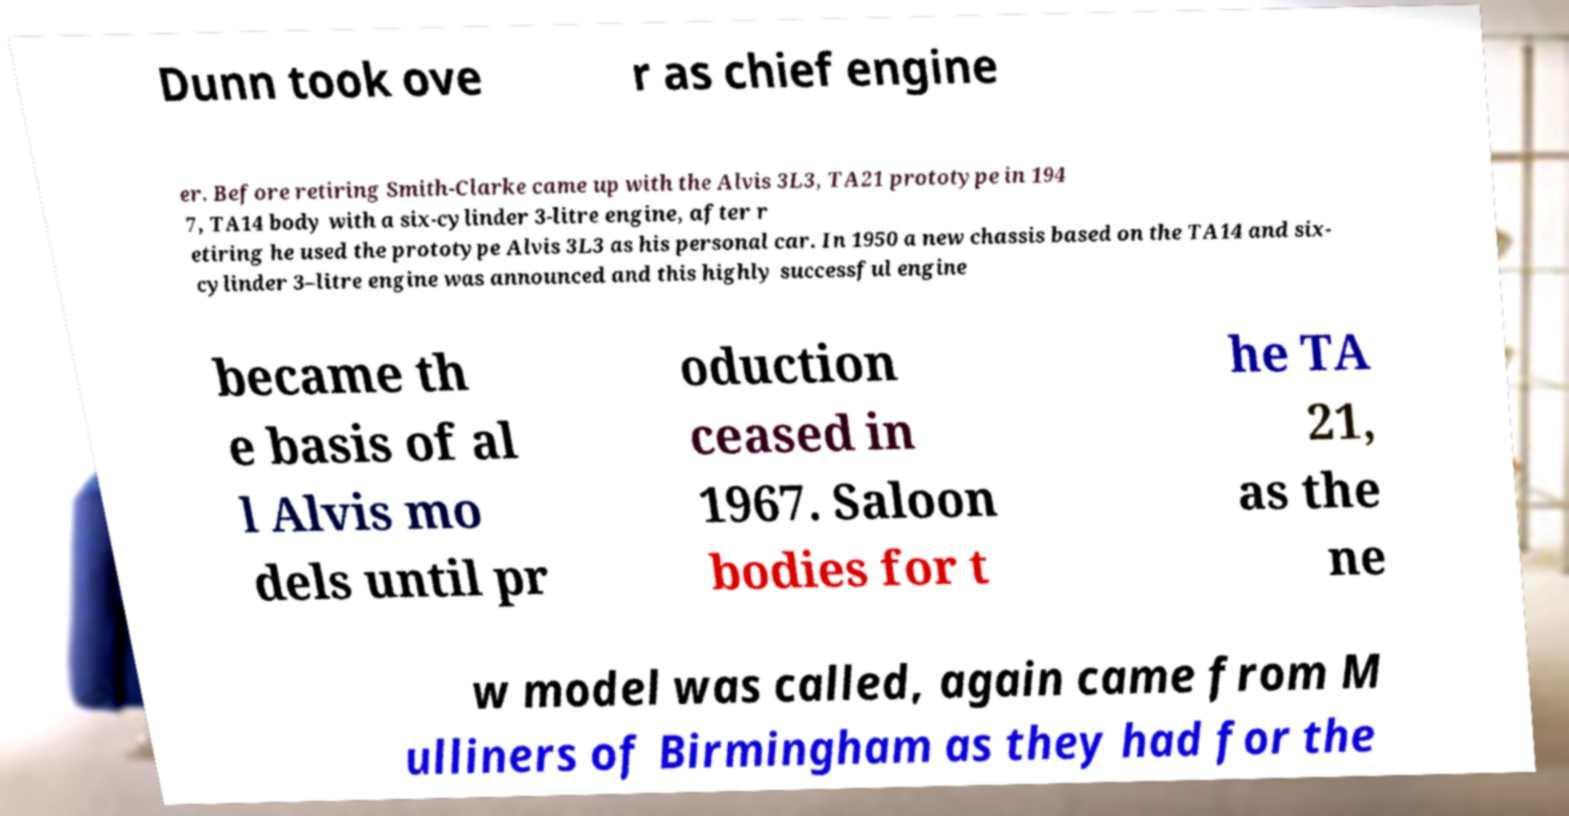There's text embedded in this image that I need extracted. Can you transcribe it verbatim? Dunn took ove r as chief engine er. Before retiring Smith-Clarke came up with the Alvis 3L3, TA21 prototype in 194 7, TA14 body with a six-cylinder 3-litre engine, after r etiring he used the prototype Alvis 3L3 as his personal car. In 1950 a new chassis based on the TA14 and six- cylinder 3–litre engine was announced and this highly successful engine became th e basis of al l Alvis mo dels until pr oduction ceased in 1967. Saloon bodies for t he TA 21, as the ne w model was called, again came from M ulliners of Birmingham as they had for the 